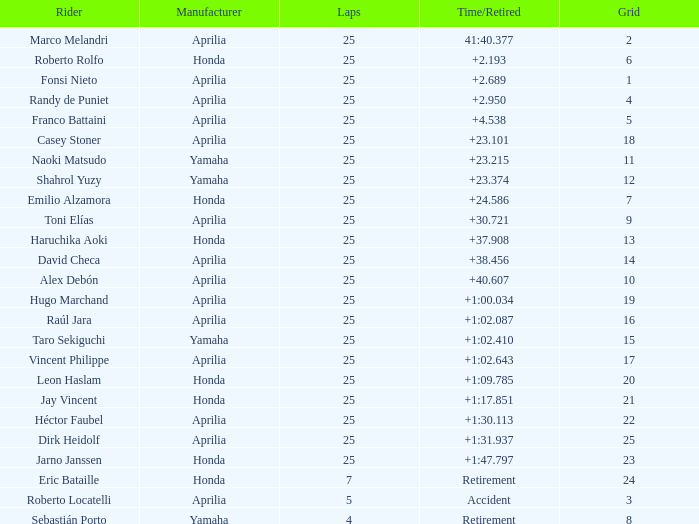797? 23.0. 